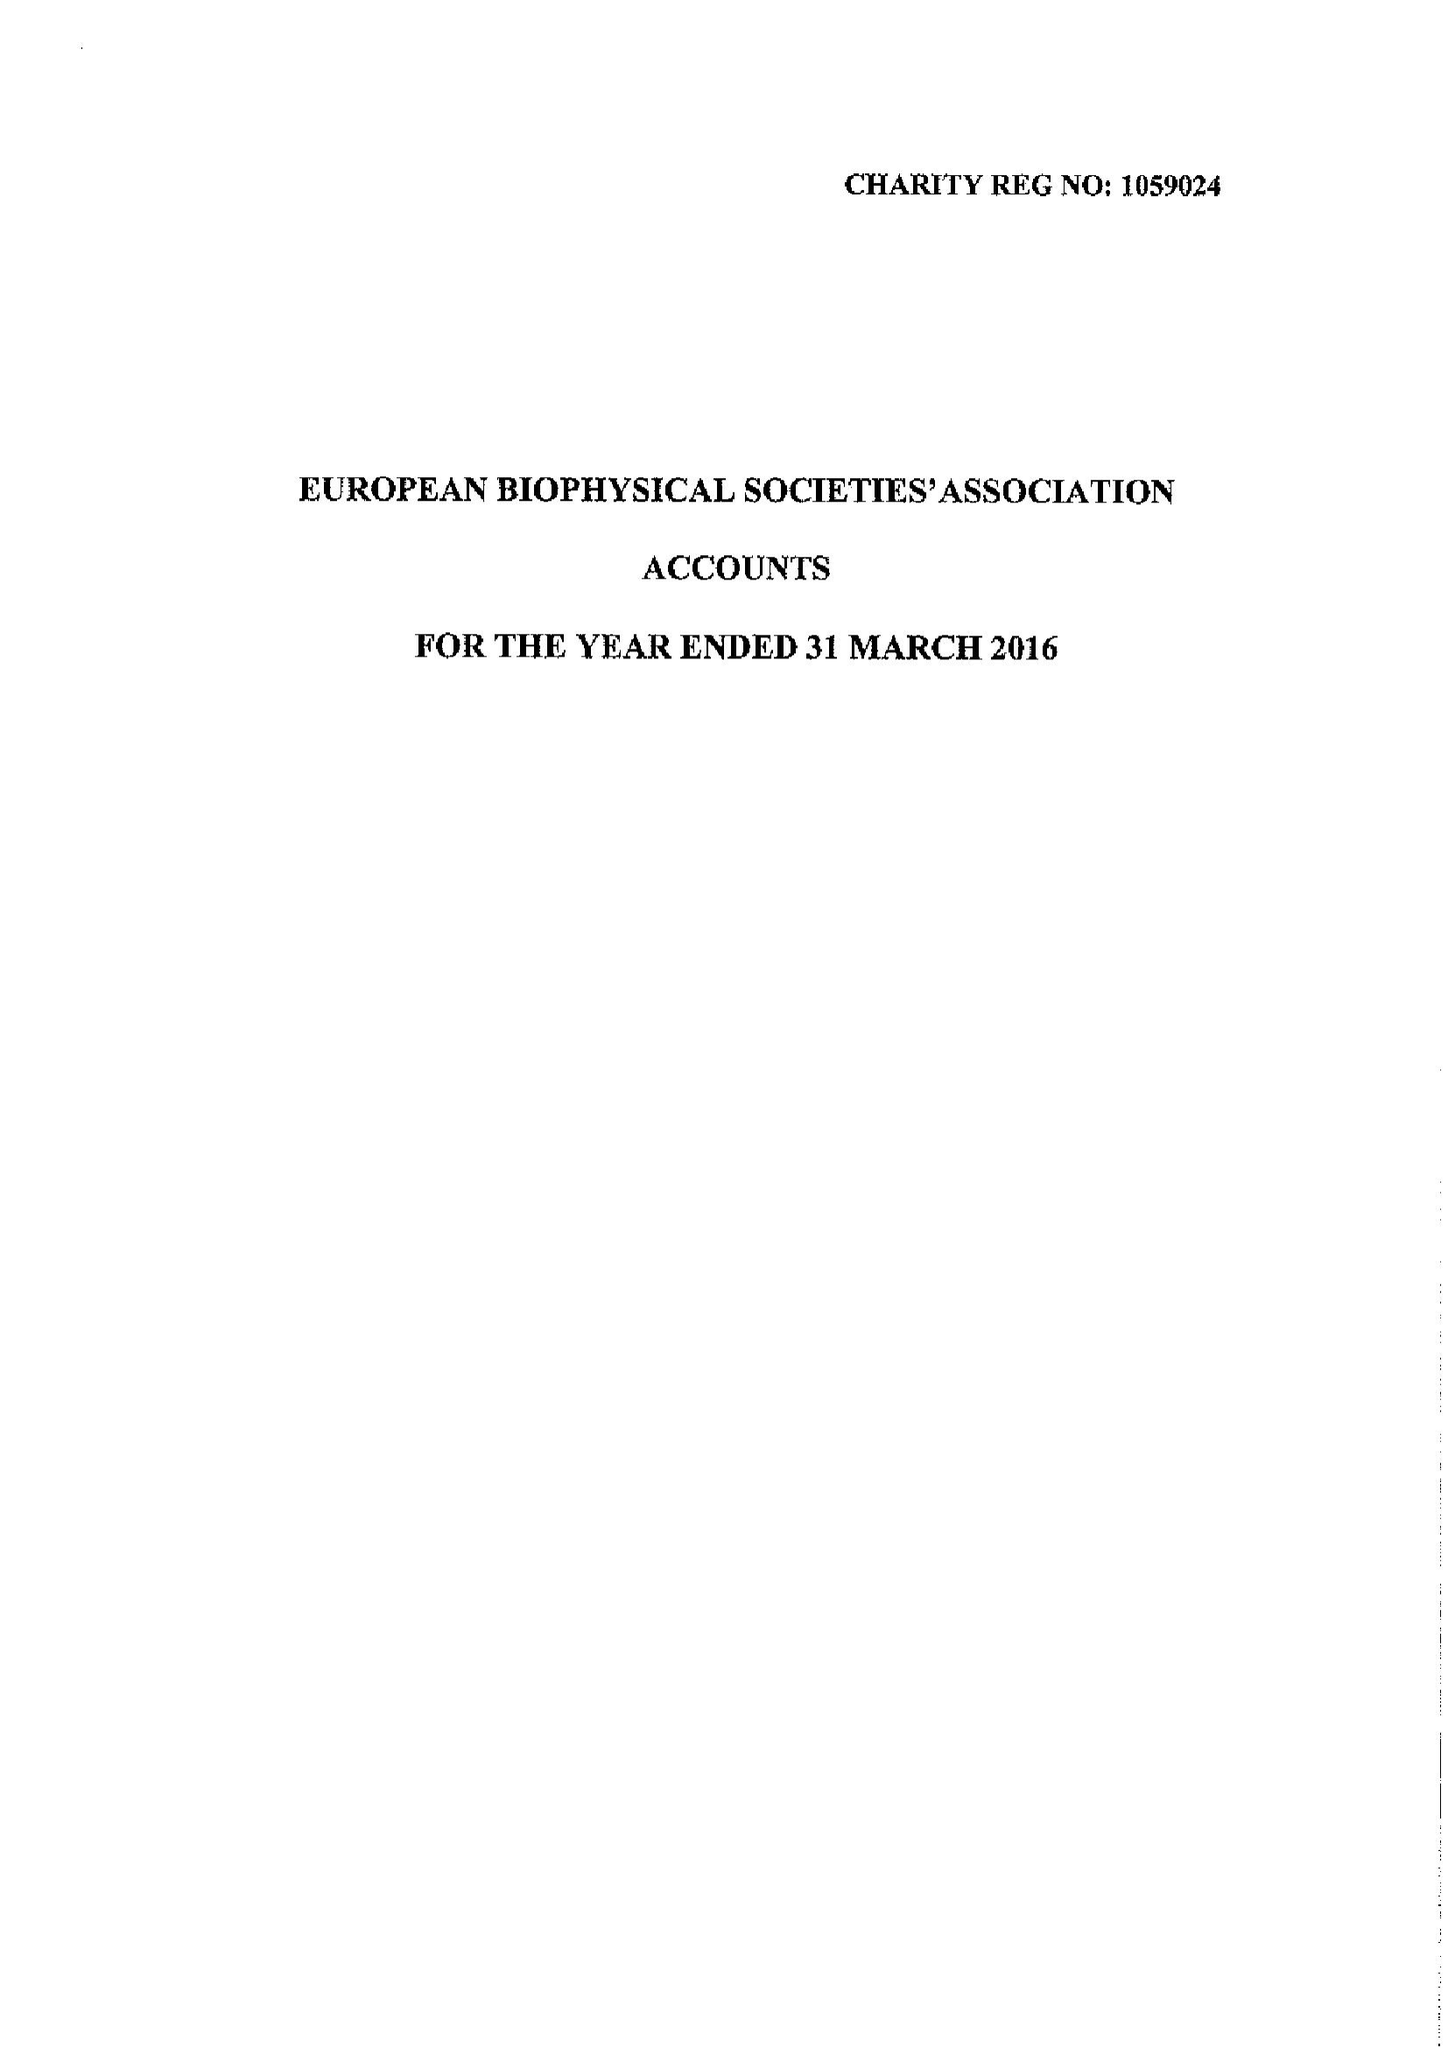What is the value for the spending_annually_in_british_pounds?
Answer the question using a single word or phrase. 85431.00 